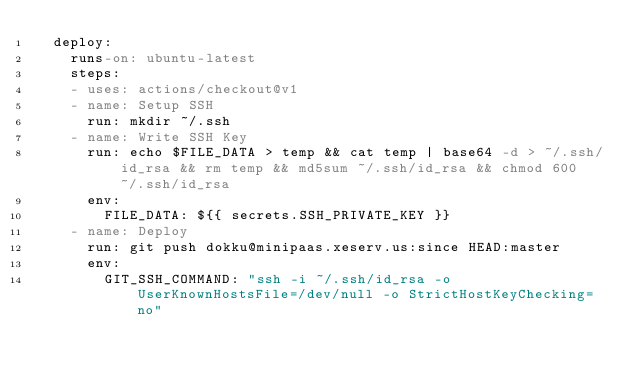Convert code to text. <code><loc_0><loc_0><loc_500><loc_500><_YAML_>  deploy:
    runs-on: ubuntu-latest
    steps:
    - uses: actions/checkout@v1
    - name: Setup SSH
      run: mkdir ~/.ssh
    - name: Write SSH Key
      run: echo $FILE_DATA > temp && cat temp | base64 -d > ~/.ssh/id_rsa && rm temp && md5sum ~/.ssh/id_rsa && chmod 600 ~/.ssh/id_rsa
      env:
        FILE_DATA: ${{ secrets.SSH_PRIVATE_KEY }}
    - name: Deploy
      run: git push dokku@minipaas.xeserv.us:since HEAD:master
      env:
        GIT_SSH_COMMAND: "ssh -i ~/.ssh/id_rsa -o UserKnownHostsFile=/dev/null -o StrictHostKeyChecking=no"
</code> 